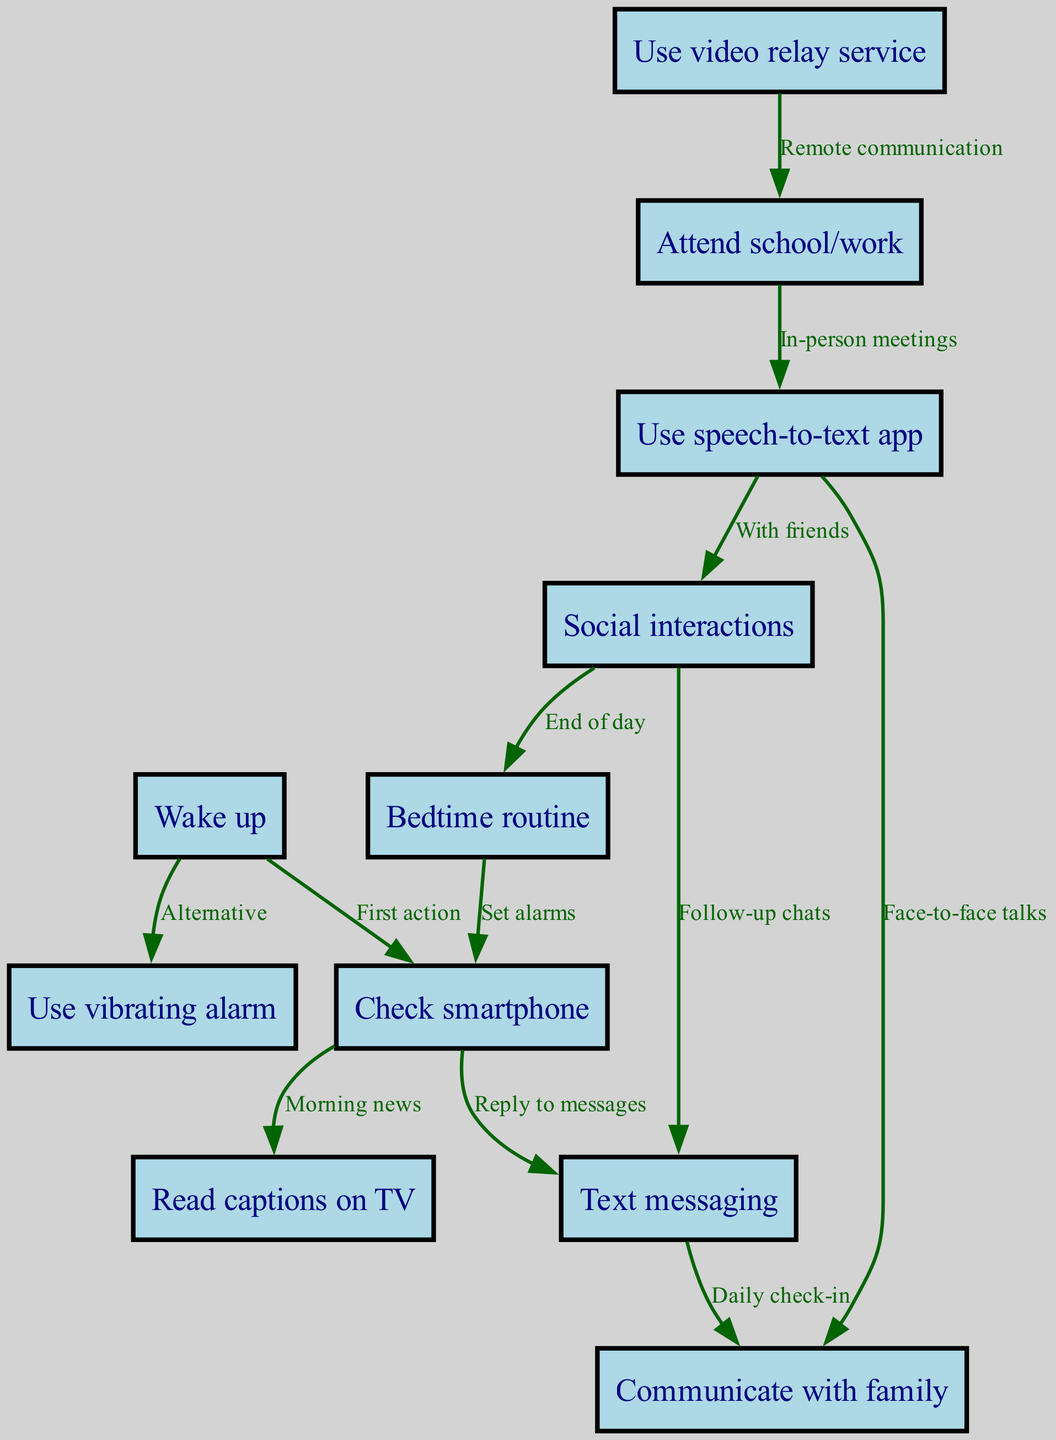What's the total number of nodes in the diagram? By counting the distinct nodes listed in the diagram, we find there are 11 nodes representing different stages or methods of communication.
Answer: 11 How does one communicate with family after texting? In the diagram, we see that after "Text messaging," the next connection leads to "Communicate with family," indicating that texting serves as a daily check-in with family.
Answer: Communicate with family What action can be taken immediately upon waking up? The diagram identifies two options after "Wake up": "Check smartphone" which is labeled as the first action, and "Use vibrating alarm" which is an alternative.
Answer: Check smartphone What do you do after checking your smartphone according to the flowchart? After "Check smartphone," the next action indicated is to "Read captions on TV" for morning news or "Text messaging" for replying to messages. This provides two potential follow-up actions.
Answer: Read captions on TV or Text messaging How many different communication methods are used to talk with family? The diagram shows two methods: "Text messaging" leading to "Communicate with family" and "Use speech-to-text app," also leading to "Communicate with family." Thus, there are two distinct communication methods.
Answer: Two What is the relationship between "Attend school/work" and "Use speech-to-text app"? According to the diagram, the edge from "Attend school/work" to "Use speech-to-text app" indicates that it is utilized during in-person meetings, highlighting its role in facilitating communication in a school or work setting.
Answer: In-person meetings What action follows "Social interactions" in the diagram? The diagram depicts an edge from "Social interactions" that leads to "Text messaging" for follow-up chats and another edge that connects to "Bedtime routine" indicating the conclusion of interactions for the day.
Answer: Text messaging or Bedtime routine What is the purpose of the "Use video relay service" node? "Use video relay service" is connected to "Attend school/work," suggesting its role in facilitating remote communication, hence enabling effective interactions in educational or professional contexts.
Answer: Remote communication 